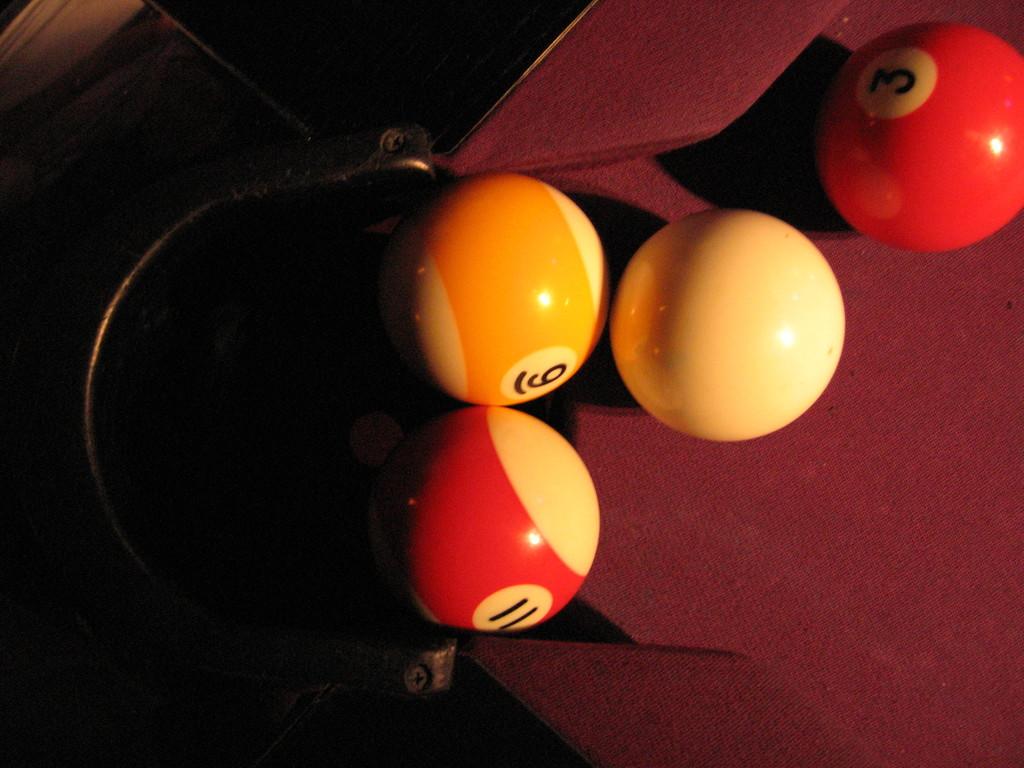What numbers are visible on the balls?
Offer a very short reply. 11, 6, 3. What number is the solid red ball?
Your answer should be very brief. 3. 